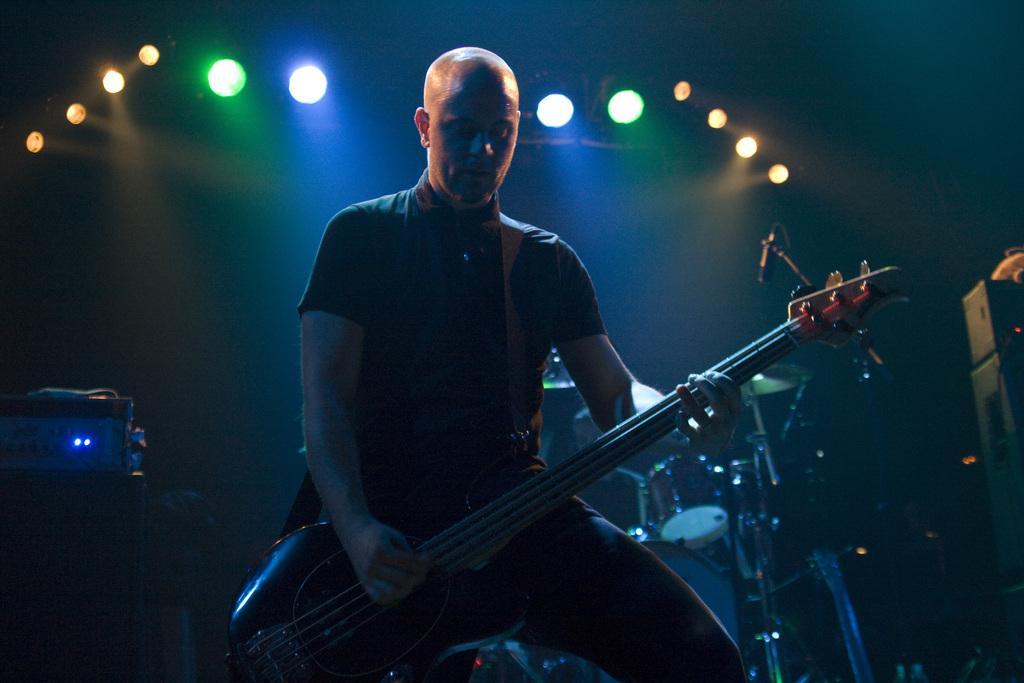Can you describe this image briefly? In this image there is a man sitting and playing guitar, beside him there are so many other musical instruments. 